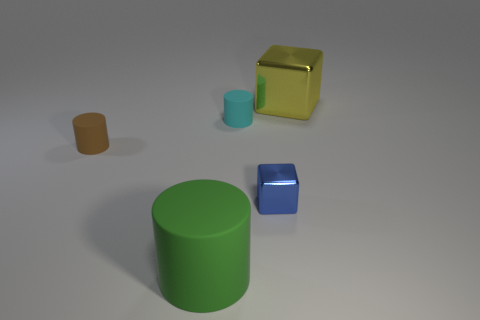Subtract all big cylinders. How many cylinders are left? 2 Add 2 cylinders. How many objects exist? 7 Subtract all cyan cylinders. How many cylinders are left? 2 Subtract all cylinders. How many objects are left? 2 Subtract 2 cubes. How many cubes are left? 0 Subtract all gray blocks. Subtract all green cylinders. How many blocks are left? 2 Subtract all small brown metallic blocks. Subtract all small rubber cylinders. How many objects are left? 3 Add 4 metallic objects. How many metallic objects are left? 6 Add 5 big yellow shiny cubes. How many big yellow shiny cubes exist? 6 Subtract 0 green balls. How many objects are left? 5 